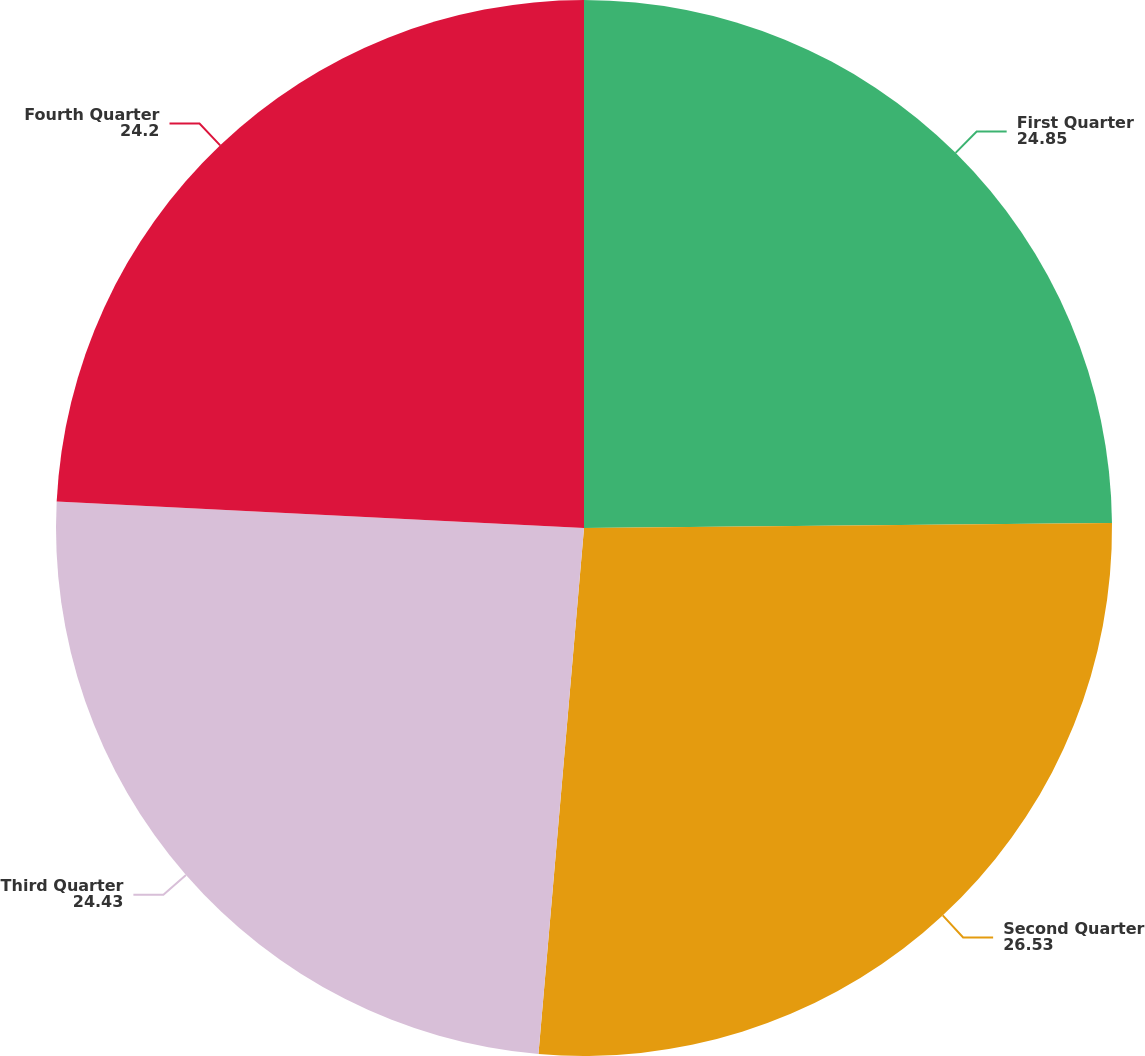Convert chart. <chart><loc_0><loc_0><loc_500><loc_500><pie_chart><fcel>First Quarter<fcel>Second Quarter<fcel>Third Quarter<fcel>Fourth Quarter<nl><fcel>24.85%<fcel>26.53%<fcel>24.43%<fcel>24.2%<nl></chart> 